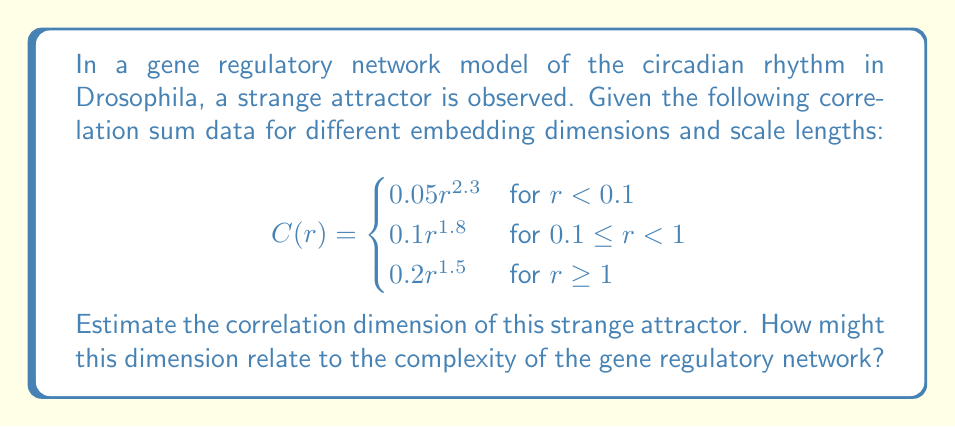Solve this math problem. To estimate the correlation dimension of the strange attractor, we'll follow these steps:

1) The correlation dimension is defined as the slope of the log-log plot of the correlation sum $C(r)$ versus the scale length $r$ in the limit as $r$ approaches 0.

2) In this case, we have a piecewise function for $C(r)$. We're interested in the behavior as $r$ approaches 0, so we'll focus on the first piece of the function:

   $$C(r) = 0.05r^{2.3} \text{ for } r < 0.1$$

3) Taking the logarithm of both sides:

   $$\log C(r) = \log(0.05) + 2.3 \log(r)$$

4) The correlation dimension $D_2$ is the slope of this log-log plot:

   $$D_2 = \lim_{r \to 0} \frac{d \log C(r)}{d \log r} = 2.3$$

5) Therefore, the correlation dimension of the strange attractor is approximately 2.3.

This non-integer dimension suggests a fractal structure in the attractor, which is characteristic of strange attractors in chaotic systems.

Relating this to the gene regulatory network:
- A correlation dimension of 2.3 indicates a system more complex than a simple periodic oscillator (which would have an integer dimension) but less complex than a fully three-dimensional system.
- This fractional dimension suggests that the gene regulatory network has a rich, non-linear dynamic behavior, potentially allowing for complex responses to environmental stimuli.
- The dimensionality might reflect the number of key genes or protein interactions that dominate the behavior of the circadian rhythm system in Drosophila.
- Understanding this dimension could help in identifying the minimum number of variables needed to model the system accurately, which is crucial for creating simplified yet effective models of gene regulatory networks in biology.
Answer: $D_2 \approx 2.3$ 